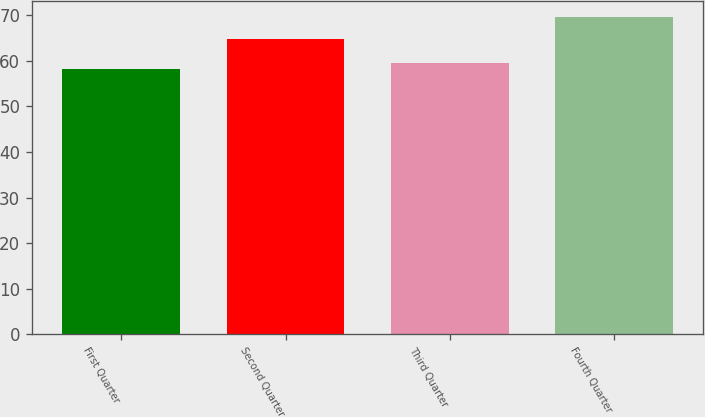Convert chart to OTSL. <chart><loc_0><loc_0><loc_500><loc_500><bar_chart><fcel>First Quarter<fcel>Second Quarter<fcel>Third Quarter<fcel>Fourth Quarter<nl><fcel>58.3<fcel>64.8<fcel>59.44<fcel>69.71<nl></chart> 